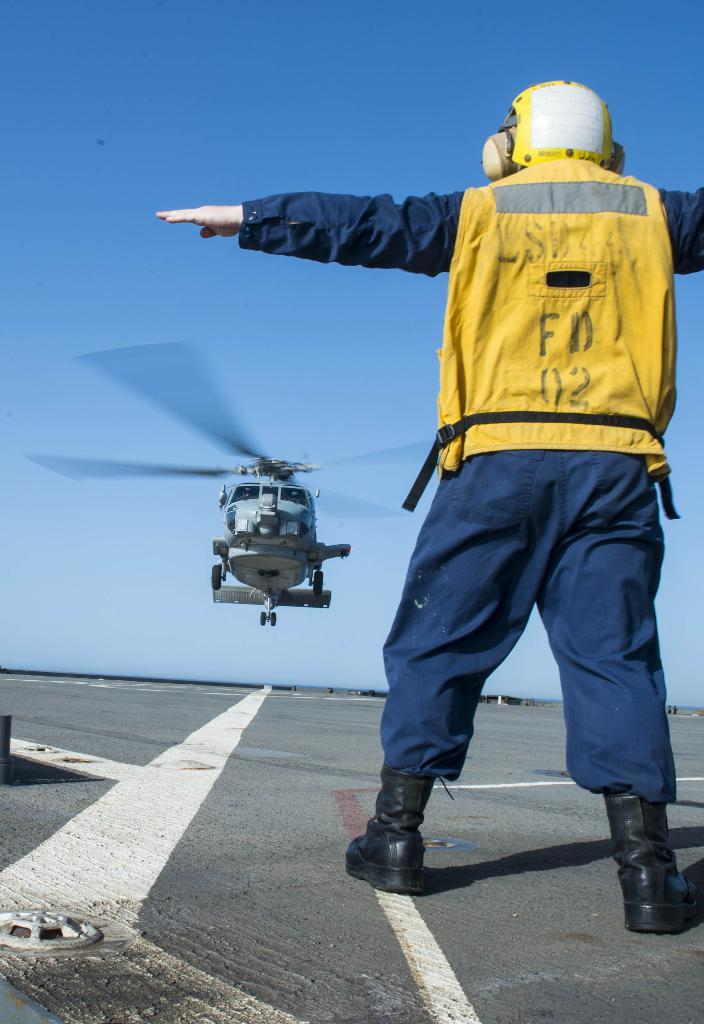<image>
Offer a succinct explanation of the picture presented. the man in the FD 02 vest is waving in a helicopter 